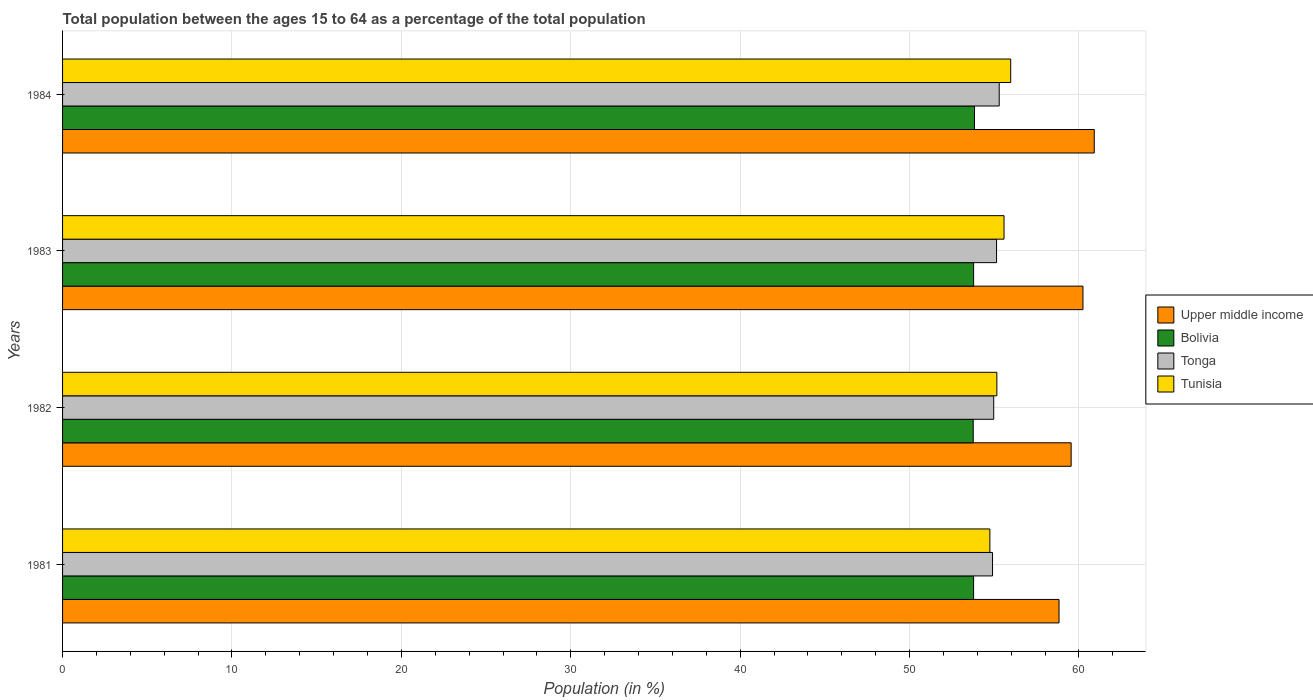How many groups of bars are there?
Your response must be concise. 4. Are the number of bars on each tick of the Y-axis equal?
Your answer should be compact. Yes. How many bars are there on the 1st tick from the top?
Provide a succinct answer. 4. What is the label of the 4th group of bars from the top?
Your answer should be very brief. 1981. What is the percentage of the population ages 15 to 64 in Upper middle income in 1982?
Offer a very short reply. 59.54. Across all years, what is the maximum percentage of the population ages 15 to 64 in Tonga?
Provide a succinct answer. 55.29. Across all years, what is the minimum percentage of the population ages 15 to 64 in Upper middle income?
Your answer should be very brief. 58.82. In which year was the percentage of the population ages 15 to 64 in Tonga minimum?
Provide a short and direct response. 1981. What is the total percentage of the population ages 15 to 64 in Upper middle income in the graph?
Provide a succinct answer. 239.5. What is the difference between the percentage of the population ages 15 to 64 in Upper middle income in 1982 and that in 1984?
Keep it short and to the point. -1.36. What is the difference between the percentage of the population ages 15 to 64 in Upper middle income in 1983 and the percentage of the population ages 15 to 64 in Tonga in 1982?
Offer a terse response. 5.27. What is the average percentage of the population ages 15 to 64 in Bolivia per year?
Your answer should be compact. 53.79. In the year 1981, what is the difference between the percentage of the population ages 15 to 64 in Tonga and percentage of the population ages 15 to 64 in Upper middle income?
Keep it short and to the point. -3.93. In how many years, is the percentage of the population ages 15 to 64 in Upper middle income greater than 46 ?
Your answer should be very brief. 4. What is the ratio of the percentage of the population ages 15 to 64 in Tunisia in 1983 to that in 1984?
Give a very brief answer. 0.99. Is the percentage of the population ages 15 to 64 in Tunisia in 1981 less than that in 1983?
Ensure brevity in your answer.  Yes. Is the difference between the percentage of the population ages 15 to 64 in Tonga in 1981 and 1984 greater than the difference between the percentage of the population ages 15 to 64 in Upper middle income in 1981 and 1984?
Provide a short and direct response. Yes. What is the difference between the highest and the second highest percentage of the population ages 15 to 64 in Bolivia?
Your answer should be compact. 0.05. What is the difference between the highest and the lowest percentage of the population ages 15 to 64 in Upper middle income?
Your response must be concise. 2.08. In how many years, is the percentage of the population ages 15 to 64 in Tunisia greater than the average percentage of the population ages 15 to 64 in Tunisia taken over all years?
Your answer should be compact. 2. Is the sum of the percentage of the population ages 15 to 64 in Tunisia in 1983 and 1984 greater than the maximum percentage of the population ages 15 to 64 in Upper middle income across all years?
Your answer should be compact. Yes. What does the 4th bar from the top in 1984 represents?
Provide a short and direct response. Upper middle income. What does the 1st bar from the bottom in 1982 represents?
Offer a terse response. Upper middle income. Are the values on the major ticks of X-axis written in scientific E-notation?
Your answer should be compact. No. Does the graph contain any zero values?
Your answer should be very brief. No. Does the graph contain grids?
Keep it short and to the point. Yes. Where does the legend appear in the graph?
Offer a terse response. Center right. How many legend labels are there?
Give a very brief answer. 4. What is the title of the graph?
Your answer should be compact. Total population between the ages 15 to 64 as a percentage of the total population. Does "High income" appear as one of the legend labels in the graph?
Your answer should be compact. No. What is the Population (in %) of Upper middle income in 1981?
Offer a terse response. 58.82. What is the Population (in %) of Bolivia in 1981?
Provide a succinct answer. 53.78. What is the Population (in %) in Tonga in 1981?
Keep it short and to the point. 54.9. What is the Population (in %) of Tunisia in 1981?
Offer a very short reply. 54.74. What is the Population (in %) of Upper middle income in 1982?
Your answer should be compact. 59.54. What is the Population (in %) in Bolivia in 1982?
Provide a succinct answer. 53.76. What is the Population (in %) in Tonga in 1982?
Offer a very short reply. 54.97. What is the Population (in %) of Tunisia in 1982?
Offer a very short reply. 55.15. What is the Population (in %) in Upper middle income in 1983?
Your response must be concise. 60.24. What is the Population (in %) in Bolivia in 1983?
Provide a short and direct response. 53.78. What is the Population (in %) of Tonga in 1983?
Provide a short and direct response. 55.14. What is the Population (in %) of Tunisia in 1983?
Offer a terse response. 55.58. What is the Population (in %) of Upper middle income in 1984?
Your answer should be compact. 60.9. What is the Population (in %) in Bolivia in 1984?
Your answer should be compact. 53.83. What is the Population (in %) of Tonga in 1984?
Your answer should be compact. 55.29. What is the Population (in %) of Tunisia in 1984?
Keep it short and to the point. 55.97. Across all years, what is the maximum Population (in %) in Upper middle income?
Your response must be concise. 60.9. Across all years, what is the maximum Population (in %) of Bolivia?
Make the answer very short. 53.83. Across all years, what is the maximum Population (in %) of Tonga?
Make the answer very short. 55.29. Across all years, what is the maximum Population (in %) of Tunisia?
Offer a very short reply. 55.97. Across all years, what is the minimum Population (in %) of Upper middle income?
Offer a very short reply. 58.82. Across all years, what is the minimum Population (in %) of Bolivia?
Keep it short and to the point. 53.76. Across all years, what is the minimum Population (in %) of Tonga?
Provide a succinct answer. 54.9. Across all years, what is the minimum Population (in %) in Tunisia?
Provide a succinct answer. 54.74. What is the total Population (in %) of Upper middle income in the graph?
Provide a succinct answer. 239.5. What is the total Population (in %) in Bolivia in the graph?
Provide a succinct answer. 215.15. What is the total Population (in %) of Tonga in the graph?
Ensure brevity in your answer.  220.3. What is the total Population (in %) of Tunisia in the graph?
Offer a very short reply. 221.44. What is the difference between the Population (in %) of Upper middle income in 1981 and that in 1982?
Offer a terse response. -0.71. What is the difference between the Population (in %) in Bolivia in 1981 and that in 1982?
Keep it short and to the point. 0.02. What is the difference between the Population (in %) of Tonga in 1981 and that in 1982?
Give a very brief answer. -0.07. What is the difference between the Population (in %) in Tunisia in 1981 and that in 1982?
Provide a short and direct response. -0.41. What is the difference between the Population (in %) of Upper middle income in 1981 and that in 1983?
Your response must be concise. -1.41. What is the difference between the Population (in %) of Bolivia in 1981 and that in 1983?
Your answer should be compact. -0. What is the difference between the Population (in %) in Tonga in 1981 and that in 1983?
Ensure brevity in your answer.  -0.24. What is the difference between the Population (in %) of Tunisia in 1981 and that in 1983?
Make the answer very short. -0.84. What is the difference between the Population (in %) of Upper middle income in 1981 and that in 1984?
Provide a succinct answer. -2.08. What is the difference between the Population (in %) of Bolivia in 1981 and that in 1984?
Keep it short and to the point. -0.05. What is the difference between the Population (in %) of Tonga in 1981 and that in 1984?
Keep it short and to the point. -0.4. What is the difference between the Population (in %) of Tunisia in 1981 and that in 1984?
Offer a terse response. -1.23. What is the difference between the Population (in %) in Upper middle income in 1982 and that in 1983?
Ensure brevity in your answer.  -0.7. What is the difference between the Population (in %) of Bolivia in 1982 and that in 1983?
Ensure brevity in your answer.  -0.02. What is the difference between the Population (in %) of Tonga in 1982 and that in 1983?
Provide a short and direct response. -0.17. What is the difference between the Population (in %) of Tunisia in 1982 and that in 1983?
Your response must be concise. -0.42. What is the difference between the Population (in %) of Upper middle income in 1982 and that in 1984?
Give a very brief answer. -1.36. What is the difference between the Population (in %) of Bolivia in 1982 and that in 1984?
Ensure brevity in your answer.  -0.08. What is the difference between the Population (in %) of Tonga in 1982 and that in 1984?
Give a very brief answer. -0.32. What is the difference between the Population (in %) in Tunisia in 1982 and that in 1984?
Offer a terse response. -0.82. What is the difference between the Population (in %) in Upper middle income in 1983 and that in 1984?
Provide a succinct answer. -0.67. What is the difference between the Population (in %) of Bolivia in 1983 and that in 1984?
Your answer should be very brief. -0.05. What is the difference between the Population (in %) of Tonga in 1983 and that in 1984?
Provide a short and direct response. -0.16. What is the difference between the Population (in %) in Tunisia in 1983 and that in 1984?
Your response must be concise. -0.39. What is the difference between the Population (in %) in Upper middle income in 1981 and the Population (in %) in Bolivia in 1982?
Ensure brevity in your answer.  5.07. What is the difference between the Population (in %) of Upper middle income in 1981 and the Population (in %) of Tonga in 1982?
Offer a terse response. 3.86. What is the difference between the Population (in %) in Upper middle income in 1981 and the Population (in %) in Tunisia in 1982?
Your answer should be very brief. 3.67. What is the difference between the Population (in %) of Bolivia in 1981 and the Population (in %) of Tonga in 1982?
Give a very brief answer. -1.19. What is the difference between the Population (in %) of Bolivia in 1981 and the Population (in %) of Tunisia in 1982?
Provide a short and direct response. -1.37. What is the difference between the Population (in %) of Tonga in 1981 and the Population (in %) of Tunisia in 1982?
Offer a very short reply. -0.26. What is the difference between the Population (in %) of Upper middle income in 1981 and the Population (in %) of Bolivia in 1983?
Give a very brief answer. 5.04. What is the difference between the Population (in %) of Upper middle income in 1981 and the Population (in %) of Tonga in 1983?
Give a very brief answer. 3.69. What is the difference between the Population (in %) in Upper middle income in 1981 and the Population (in %) in Tunisia in 1983?
Give a very brief answer. 3.25. What is the difference between the Population (in %) in Bolivia in 1981 and the Population (in %) in Tonga in 1983?
Ensure brevity in your answer.  -1.36. What is the difference between the Population (in %) of Bolivia in 1981 and the Population (in %) of Tunisia in 1983?
Offer a terse response. -1.8. What is the difference between the Population (in %) of Tonga in 1981 and the Population (in %) of Tunisia in 1983?
Give a very brief answer. -0.68. What is the difference between the Population (in %) in Upper middle income in 1981 and the Population (in %) in Bolivia in 1984?
Keep it short and to the point. 4.99. What is the difference between the Population (in %) of Upper middle income in 1981 and the Population (in %) of Tonga in 1984?
Offer a very short reply. 3.53. What is the difference between the Population (in %) in Upper middle income in 1981 and the Population (in %) in Tunisia in 1984?
Provide a succinct answer. 2.85. What is the difference between the Population (in %) in Bolivia in 1981 and the Population (in %) in Tonga in 1984?
Ensure brevity in your answer.  -1.51. What is the difference between the Population (in %) of Bolivia in 1981 and the Population (in %) of Tunisia in 1984?
Your answer should be very brief. -2.19. What is the difference between the Population (in %) in Tonga in 1981 and the Population (in %) in Tunisia in 1984?
Keep it short and to the point. -1.07. What is the difference between the Population (in %) of Upper middle income in 1982 and the Population (in %) of Bolivia in 1983?
Your response must be concise. 5.76. What is the difference between the Population (in %) in Upper middle income in 1982 and the Population (in %) in Tonga in 1983?
Your response must be concise. 4.4. What is the difference between the Population (in %) in Upper middle income in 1982 and the Population (in %) in Tunisia in 1983?
Your answer should be compact. 3.96. What is the difference between the Population (in %) in Bolivia in 1982 and the Population (in %) in Tonga in 1983?
Give a very brief answer. -1.38. What is the difference between the Population (in %) in Bolivia in 1982 and the Population (in %) in Tunisia in 1983?
Ensure brevity in your answer.  -1.82. What is the difference between the Population (in %) of Tonga in 1982 and the Population (in %) of Tunisia in 1983?
Make the answer very short. -0.61. What is the difference between the Population (in %) in Upper middle income in 1982 and the Population (in %) in Bolivia in 1984?
Keep it short and to the point. 5.7. What is the difference between the Population (in %) in Upper middle income in 1982 and the Population (in %) in Tonga in 1984?
Give a very brief answer. 4.25. What is the difference between the Population (in %) of Upper middle income in 1982 and the Population (in %) of Tunisia in 1984?
Your response must be concise. 3.57. What is the difference between the Population (in %) in Bolivia in 1982 and the Population (in %) in Tonga in 1984?
Your response must be concise. -1.53. What is the difference between the Population (in %) of Bolivia in 1982 and the Population (in %) of Tunisia in 1984?
Your response must be concise. -2.21. What is the difference between the Population (in %) of Tonga in 1982 and the Population (in %) of Tunisia in 1984?
Offer a very short reply. -1. What is the difference between the Population (in %) in Upper middle income in 1983 and the Population (in %) in Bolivia in 1984?
Make the answer very short. 6.4. What is the difference between the Population (in %) of Upper middle income in 1983 and the Population (in %) of Tonga in 1984?
Your answer should be very brief. 4.94. What is the difference between the Population (in %) in Upper middle income in 1983 and the Population (in %) in Tunisia in 1984?
Ensure brevity in your answer.  4.26. What is the difference between the Population (in %) of Bolivia in 1983 and the Population (in %) of Tonga in 1984?
Offer a terse response. -1.51. What is the difference between the Population (in %) of Bolivia in 1983 and the Population (in %) of Tunisia in 1984?
Provide a succinct answer. -2.19. What is the difference between the Population (in %) in Tonga in 1983 and the Population (in %) in Tunisia in 1984?
Provide a succinct answer. -0.83. What is the average Population (in %) in Upper middle income per year?
Provide a short and direct response. 59.87. What is the average Population (in %) in Bolivia per year?
Make the answer very short. 53.79. What is the average Population (in %) of Tonga per year?
Provide a succinct answer. 55.07. What is the average Population (in %) of Tunisia per year?
Provide a short and direct response. 55.36. In the year 1981, what is the difference between the Population (in %) of Upper middle income and Population (in %) of Bolivia?
Give a very brief answer. 5.04. In the year 1981, what is the difference between the Population (in %) in Upper middle income and Population (in %) in Tonga?
Provide a succinct answer. 3.93. In the year 1981, what is the difference between the Population (in %) in Upper middle income and Population (in %) in Tunisia?
Keep it short and to the point. 4.08. In the year 1981, what is the difference between the Population (in %) in Bolivia and Population (in %) in Tonga?
Keep it short and to the point. -1.12. In the year 1981, what is the difference between the Population (in %) of Bolivia and Population (in %) of Tunisia?
Ensure brevity in your answer.  -0.96. In the year 1981, what is the difference between the Population (in %) of Tonga and Population (in %) of Tunisia?
Provide a succinct answer. 0.16. In the year 1982, what is the difference between the Population (in %) of Upper middle income and Population (in %) of Bolivia?
Keep it short and to the point. 5.78. In the year 1982, what is the difference between the Population (in %) in Upper middle income and Population (in %) in Tonga?
Provide a short and direct response. 4.57. In the year 1982, what is the difference between the Population (in %) of Upper middle income and Population (in %) of Tunisia?
Your answer should be compact. 4.38. In the year 1982, what is the difference between the Population (in %) in Bolivia and Population (in %) in Tonga?
Keep it short and to the point. -1.21. In the year 1982, what is the difference between the Population (in %) of Bolivia and Population (in %) of Tunisia?
Make the answer very short. -1.4. In the year 1982, what is the difference between the Population (in %) of Tonga and Population (in %) of Tunisia?
Offer a terse response. -0.19. In the year 1983, what is the difference between the Population (in %) of Upper middle income and Population (in %) of Bolivia?
Provide a succinct answer. 6.45. In the year 1983, what is the difference between the Population (in %) of Upper middle income and Population (in %) of Tonga?
Keep it short and to the point. 5.1. In the year 1983, what is the difference between the Population (in %) of Upper middle income and Population (in %) of Tunisia?
Keep it short and to the point. 4.66. In the year 1983, what is the difference between the Population (in %) of Bolivia and Population (in %) of Tonga?
Provide a short and direct response. -1.35. In the year 1983, what is the difference between the Population (in %) in Bolivia and Population (in %) in Tunisia?
Your response must be concise. -1.79. In the year 1983, what is the difference between the Population (in %) in Tonga and Population (in %) in Tunisia?
Give a very brief answer. -0.44. In the year 1984, what is the difference between the Population (in %) of Upper middle income and Population (in %) of Bolivia?
Your response must be concise. 7.07. In the year 1984, what is the difference between the Population (in %) in Upper middle income and Population (in %) in Tonga?
Offer a very short reply. 5.61. In the year 1984, what is the difference between the Population (in %) of Upper middle income and Population (in %) of Tunisia?
Keep it short and to the point. 4.93. In the year 1984, what is the difference between the Population (in %) of Bolivia and Population (in %) of Tonga?
Offer a very short reply. -1.46. In the year 1984, what is the difference between the Population (in %) in Bolivia and Population (in %) in Tunisia?
Offer a very short reply. -2.14. In the year 1984, what is the difference between the Population (in %) of Tonga and Population (in %) of Tunisia?
Your response must be concise. -0.68. What is the ratio of the Population (in %) in Upper middle income in 1981 to that in 1982?
Your response must be concise. 0.99. What is the ratio of the Population (in %) of Tonga in 1981 to that in 1982?
Your answer should be compact. 1. What is the ratio of the Population (in %) of Upper middle income in 1981 to that in 1983?
Provide a short and direct response. 0.98. What is the ratio of the Population (in %) in Tunisia in 1981 to that in 1983?
Your answer should be compact. 0.98. What is the ratio of the Population (in %) of Upper middle income in 1981 to that in 1984?
Keep it short and to the point. 0.97. What is the ratio of the Population (in %) in Tonga in 1981 to that in 1984?
Provide a succinct answer. 0.99. What is the ratio of the Population (in %) in Tunisia in 1981 to that in 1984?
Provide a succinct answer. 0.98. What is the ratio of the Population (in %) of Upper middle income in 1982 to that in 1983?
Provide a succinct answer. 0.99. What is the ratio of the Population (in %) of Bolivia in 1982 to that in 1983?
Provide a short and direct response. 1. What is the ratio of the Population (in %) of Tonga in 1982 to that in 1983?
Keep it short and to the point. 1. What is the ratio of the Population (in %) in Tunisia in 1982 to that in 1983?
Ensure brevity in your answer.  0.99. What is the ratio of the Population (in %) in Upper middle income in 1982 to that in 1984?
Provide a succinct answer. 0.98. What is the ratio of the Population (in %) of Tunisia in 1982 to that in 1984?
Make the answer very short. 0.99. What is the ratio of the Population (in %) in Bolivia in 1983 to that in 1984?
Provide a succinct answer. 1. What is the difference between the highest and the second highest Population (in %) of Upper middle income?
Your answer should be very brief. 0.67. What is the difference between the highest and the second highest Population (in %) of Bolivia?
Your response must be concise. 0.05. What is the difference between the highest and the second highest Population (in %) of Tonga?
Ensure brevity in your answer.  0.16. What is the difference between the highest and the second highest Population (in %) of Tunisia?
Provide a succinct answer. 0.39. What is the difference between the highest and the lowest Population (in %) of Upper middle income?
Ensure brevity in your answer.  2.08. What is the difference between the highest and the lowest Population (in %) of Bolivia?
Ensure brevity in your answer.  0.08. What is the difference between the highest and the lowest Population (in %) in Tonga?
Offer a very short reply. 0.4. What is the difference between the highest and the lowest Population (in %) in Tunisia?
Offer a very short reply. 1.23. 